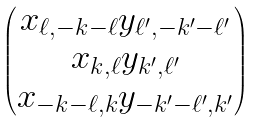Convert formula to latex. <formula><loc_0><loc_0><loc_500><loc_500>\begin{pmatrix} x _ { \ell , - k - \ell } y _ { \ell ^ { \prime } , - k ^ { \prime } - \ell ^ { \prime } } \\ x _ { k , \ell } y _ { k ^ { \prime } , \ell ^ { \prime } } \\ x _ { - k - \ell , k } y _ { - k ^ { \prime } - \ell ^ { \prime } , k ^ { \prime } } \\ \end{pmatrix}</formula> 